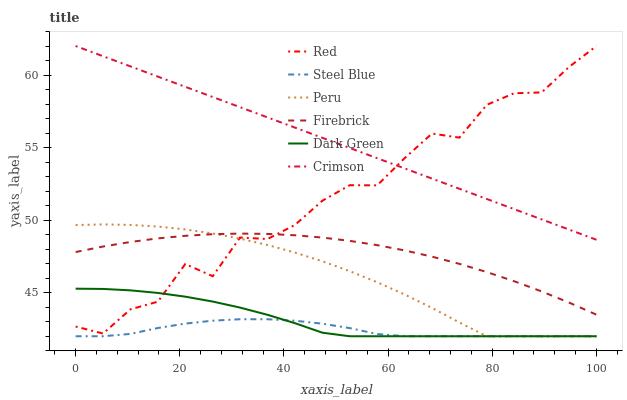Does Steel Blue have the minimum area under the curve?
Answer yes or no. Yes. Does Crimson have the maximum area under the curve?
Answer yes or no. Yes. Does Peru have the minimum area under the curve?
Answer yes or no. No. Does Peru have the maximum area under the curve?
Answer yes or no. No. Is Crimson the smoothest?
Answer yes or no. Yes. Is Red the roughest?
Answer yes or no. Yes. Is Steel Blue the smoothest?
Answer yes or no. No. Is Steel Blue the roughest?
Answer yes or no. No. Does Steel Blue have the lowest value?
Answer yes or no. Yes. Does Crimson have the lowest value?
Answer yes or no. No. Does Red have the highest value?
Answer yes or no. Yes. Does Peru have the highest value?
Answer yes or no. No. Is Dark Green less than Crimson?
Answer yes or no. Yes. Is Crimson greater than Steel Blue?
Answer yes or no. Yes. Does Red intersect Crimson?
Answer yes or no. Yes. Is Red less than Crimson?
Answer yes or no. No. Is Red greater than Crimson?
Answer yes or no. No. Does Dark Green intersect Crimson?
Answer yes or no. No. 